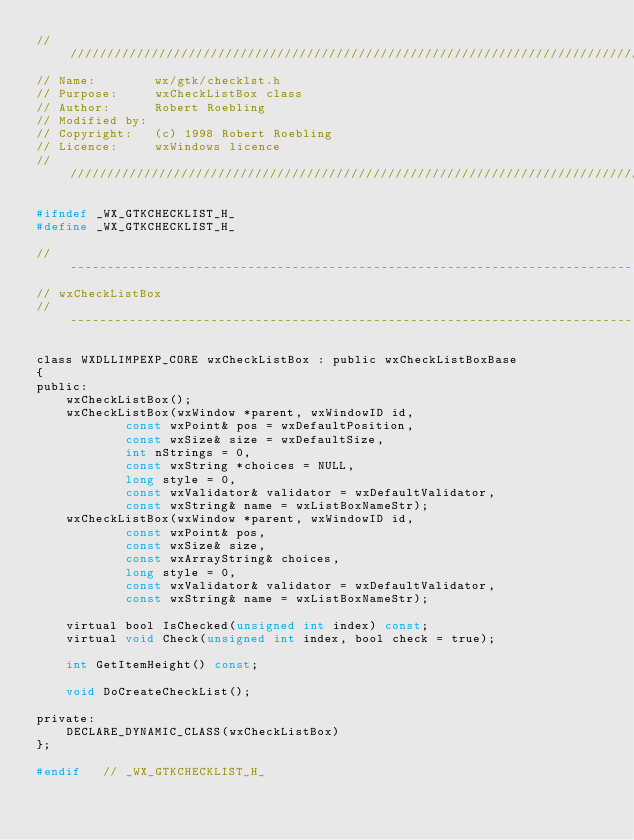<code> <loc_0><loc_0><loc_500><loc_500><_C_>///////////////////////////////////////////////////////////////////////////////
// Name:        wx/gtk/checklst.h
// Purpose:     wxCheckListBox class
// Author:      Robert Roebling
// Modified by:
// Copyright:   (c) 1998 Robert Roebling
// Licence:     wxWindows licence
///////////////////////////////////////////////////////////////////////////////

#ifndef _WX_GTKCHECKLIST_H_
#define _WX_GTKCHECKLIST_H_

//-----------------------------------------------------------------------------
// wxCheckListBox
// ----------------------------------------------------------------------------

class WXDLLIMPEXP_CORE wxCheckListBox : public wxCheckListBoxBase
{
public:
    wxCheckListBox();
    wxCheckListBox(wxWindow *parent, wxWindowID id,
            const wxPoint& pos = wxDefaultPosition,
            const wxSize& size = wxDefaultSize,
            int nStrings = 0,
            const wxString *choices = NULL,
            long style = 0,
            const wxValidator& validator = wxDefaultValidator,
            const wxString& name = wxListBoxNameStr);
    wxCheckListBox(wxWindow *parent, wxWindowID id,
            const wxPoint& pos,
            const wxSize& size,
            const wxArrayString& choices,
            long style = 0,
            const wxValidator& validator = wxDefaultValidator,
            const wxString& name = wxListBoxNameStr);

    virtual bool IsChecked(unsigned int index) const;
    virtual void Check(unsigned int index, bool check = true);

    int GetItemHeight() const;

    void DoCreateCheckList();

private:
    DECLARE_DYNAMIC_CLASS(wxCheckListBox)
};

#endif   // _WX_GTKCHECKLIST_H_
</code> 